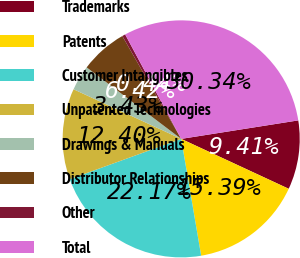Convert chart to OTSL. <chart><loc_0><loc_0><loc_500><loc_500><pie_chart><fcel>Trademarks<fcel>Patents<fcel>Customer Intangibles<fcel>Unpatented Technologies<fcel>Drawings & Manuals<fcel>Distributor Relationships<fcel>Other<fcel>Total<nl><fcel>9.41%<fcel>15.39%<fcel>22.17%<fcel>12.4%<fcel>3.43%<fcel>6.42%<fcel>0.44%<fcel>30.34%<nl></chart> 